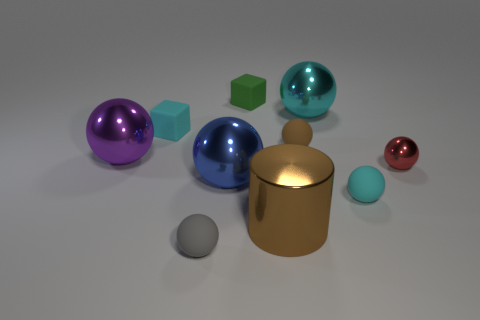Subtract all purple spheres. How many spheres are left? 6 Subtract all purple spheres. How many spheres are left? 6 Subtract all cubes. How many objects are left? 8 Add 6 brown spheres. How many brown spheres are left? 7 Add 6 purple balls. How many purple balls exist? 7 Subtract 0 blue cubes. How many objects are left? 10 Subtract 1 cubes. How many cubes are left? 1 Subtract all cyan cubes. Subtract all cyan cylinders. How many cubes are left? 1 Subtract all yellow balls. How many yellow cubes are left? 0 Subtract all large brown matte objects. Subtract all small red metallic things. How many objects are left? 9 